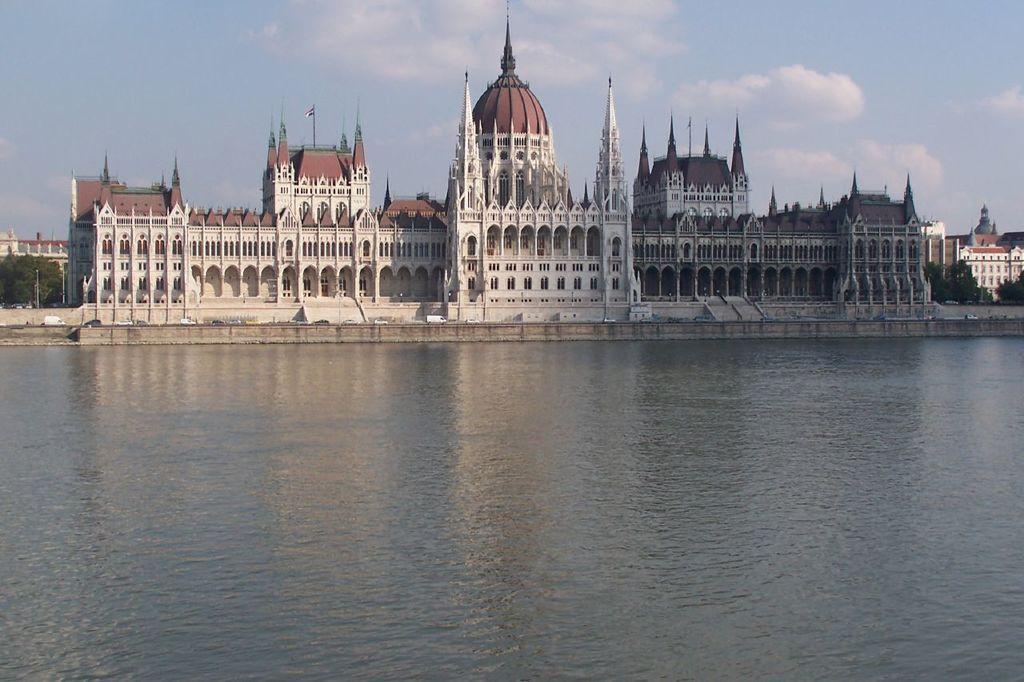Describe this image in one or two sentences. In this image I can see the water. To the side of the water I can see the buildings and the trees. In the background I can see the clouds and the sky. 